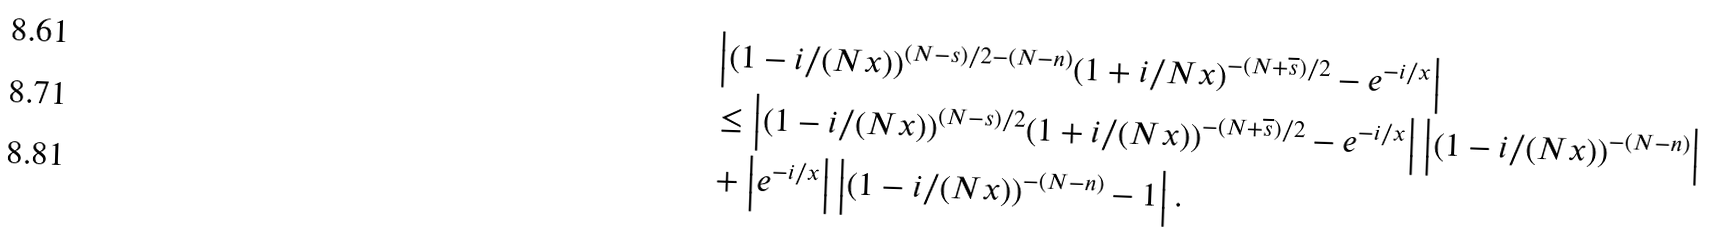Convert formula to latex. <formula><loc_0><loc_0><loc_500><loc_500>& \left | ( 1 - i / ( N x ) ) ^ { ( N - s ) / 2 - ( N - n ) } ( 1 + i / N x ) ^ { - ( N + \overline { s } ) / 2 } - e ^ { - i / x } \right | \\ & \leq \left | ( 1 - i / ( N x ) ) ^ { ( N - s ) / 2 } ( 1 + i / ( N x ) ) ^ { - ( N + \overline { s } ) / 2 } - e ^ { - i / x } \right | \left | ( 1 - i / ( N x ) ) ^ { - ( N - n ) } \right | \\ & + \left | e ^ { - i / x } \right | \left | ( 1 - i / ( N x ) ) ^ { - ( N - n ) } - 1 \right | .</formula> 